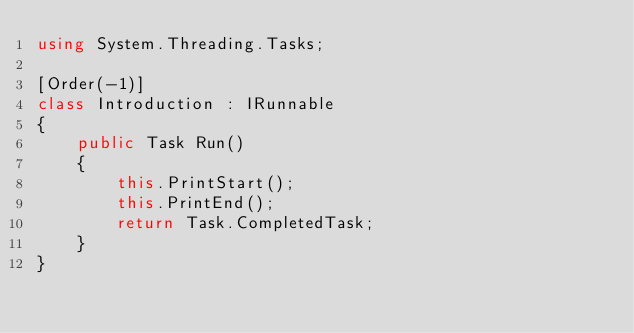<code> <loc_0><loc_0><loc_500><loc_500><_C#_>using System.Threading.Tasks;

[Order(-1)]
class Introduction : IRunnable
{
    public Task Run()
    {
        this.PrintStart();
        this.PrintEnd();
        return Task.CompletedTask;
    }
}</code> 